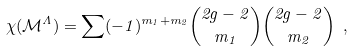<formula> <loc_0><loc_0><loc_500><loc_500>\chi ( \mathcal { M } ^ { \Lambda } ) = \sum ( - 1 ) ^ { m _ { 1 } + m _ { 2 } } \binom { 2 g - 2 } { m _ { 1 } } \binom { 2 g - 2 } { m _ { 2 } } \ ,</formula> 